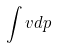<formula> <loc_0><loc_0><loc_500><loc_500>\int v d p</formula> 